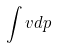<formula> <loc_0><loc_0><loc_500><loc_500>\int v d p</formula> 